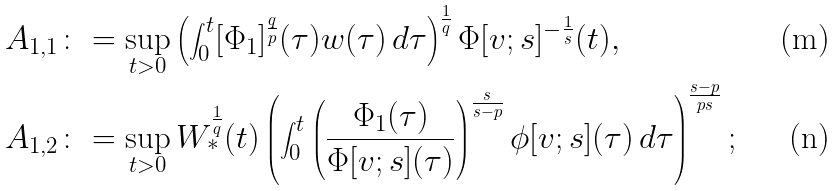<formula> <loc_0><loc_0><loc_500><loc_500>A _ { 1 , 1 } \colon & = \sup _ { t > 0 } \left ( \int _ { 0 } ^ { t } [ \Phi _ { 1 } ] ^ { \frac { q } { p } } ( \tau ) w ( \tau ) \, d \tau \right ) ^ { \frac { 1 } { q } } \Phi [ v ; s ] ^ { - \frac { 1 } { s } } ( t ) , \\ A _ { 1 , 2 } \colon & = \sup _ { t > 0 } W _ { * } ^ { \frac { 1 } { q } } ( t ) \left ( \int _ { 0 } ^ { t } \left ( \frac { \Phi _ { 1 } ( \tau ) } { \Phi [ v ; s ] ( \tau ) } \right ) ^ { \frac { s } { s - p } } \phi [ v ; s ] ( \tau ) \, d \tau \right ) ^ { \frac { s - p } { p s } } ;</formula> 